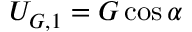Convert formula to latex. <formula><loc_0><loc_0><loc_500><loc_500>U _ { G , 1 } = G \cos { \alpha }</formula> 